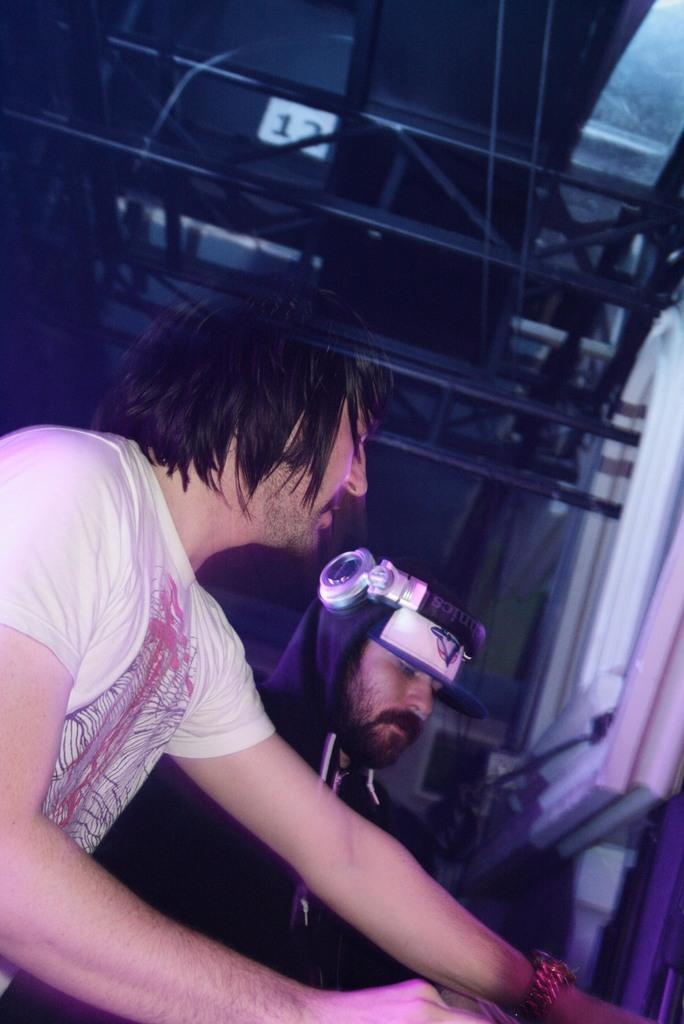How many people are in the image? There are two people in the image. What is the person at the front wearing? The person at the front is wearing a white t-shirt. What type of recess activity are the two people engaged in during the image? There is no indication of any recess activity in the image; it simply shows two people. What is the relationship between the two people in the image? The provided facts do not give any information about the relationship between the two people. How many toes can be seen in the image? There is no information about the number of toes visible in the image. 